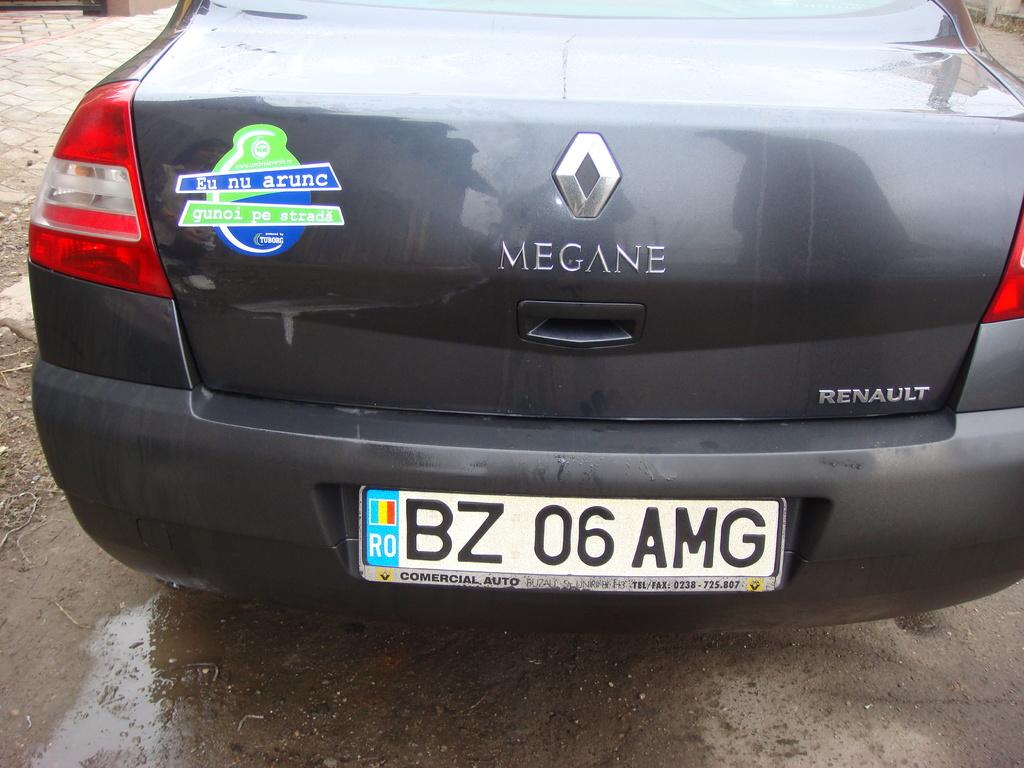<image>
Describe the image concisely. A black Renault is on a wet street. 